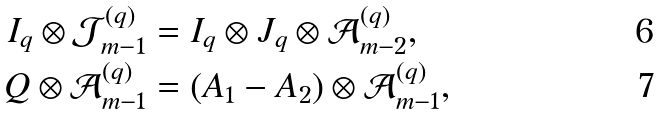<formula> <loc_0><loc_0><loc_500><loc_500>I _ { q } \otimes \mathcal { J } _ { m - 1 } ^ { ( q ) } & = I _ { q } \otimes J _ { q } \otimes \mathcal { A } _ { m - 2 } ^ { ( q ) } , \\ Q \otimes \mathcal { A } _ { m - 1 } ^ { ( q ) } & = ( A _ { 1 } - A _ { 2 } ) \otimes \mathcal { A } _ { m - 1 } ^ { ( q ) } ,</formula> 